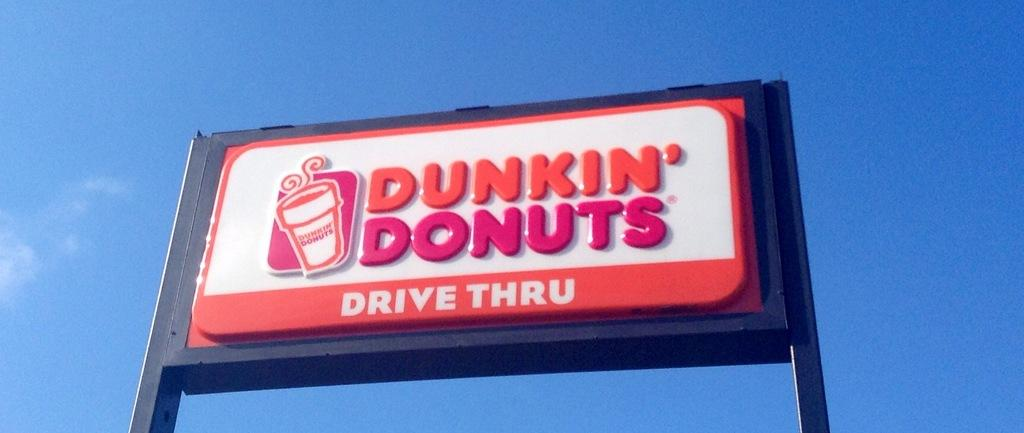<image>
Offer a succinct explanation of the picture presented. Dunkin Donuts sign that is hung high above the ground. 